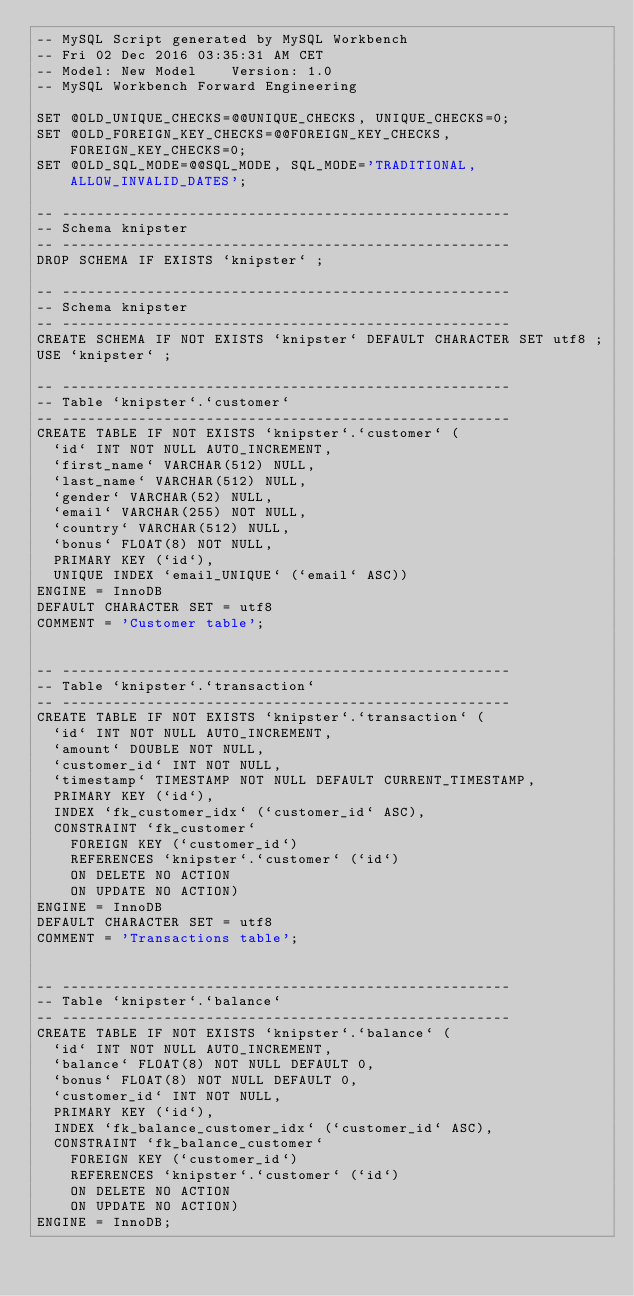<code> <loc_0><loc_0><loc_500><loc_500><_SQL_>-- MySQL Script generated by MySQL Workbench
-- Fri 02 Dec 2016 03:35:31 AM CET
-- Model: New Model    Version: 1.0
-- MySQL Workbench Forward Engineering

SET @OLD_UNIQUE_CHECKS=@@UNIQUE_CHECKS, UNIQUE_CHECKS=0;
SET @OLD_FOREIGN_KEY_CHECKS=@@FOREIGN_KEY_CHECKS, FOREIGN_KEY_CHECKS=0;
SET @OLD_SQL_MODE=@@SQL_MODE, SQL_MODE='TRADITIONAL,ALLOW_INVALID_DATES';

-- -----------------------------------------------------
-- Schema knipster
-- -----------------------------------------------------
DROP SCHEMA IF EXISTS `knipster` ;

-- -----------------------------------------------------
-- Schema knipster
-- -----------------------------------------------------
CREATE SCHEMA IF NOT EXISTS `knipster` DEFAULT CHARACTER SET utf8 ;
USE `knipster` ;

-- -----------------------------------------------------
-- Table `knipster`.`customer`
-- -----------------------------------------------------
CREATE TABLE IF NOT EXISTS `knipster`.`customer` (
  `id` INT NOT NULL AUTO_INCREMENT,
  `first_name` VARCHAR(512) NULL,
  `last_name` VARCHAR(512) NULL,
  `gender` VARCHAR(52) NULL,
  `email` VARCHAR(255) NOT NULL,
  `country` VARCHAR(512) NULL,
  `bonus` FLOAT(8) NOT NULL,
  PRIMARY KEY (`id`),
  UNIQUE INDEX `email_UNIQUE` (`email` ASC))
ENGINE = InnoDB
DEFAULT CHARACTER SET = utf8
COMMENT = 'Customer table';


-- -----------------------------------------------------
-- Table `knipster`.`transaction`
-- -----------------------------------------------------
CREATE TABLE IF NOT EXISTS `knipster`.`transaction` (
  `id` INT NOT NULL AUTO_INCREMENT,
  `amount` DOUBLE NOT NULL,
  `customer_id` INT NOT NULL,
  `timestamp` TIMESTAMP NOT NULL DEFAULT CURRENT_TIMESTAMP,
  PRIMARY KEY (`id`),
  INDEX `fk_customer_idx` (`customer_id` ASC),
  CONSTRAINT `fk_customer`
    FOREIGN KEY (`customer_id`)
    REFERENCES `knipster`.`customer` (`id`)
    ON DELETE NO ACTION
    ON UPDATE NO ACTION)
ENGINE = InnoDB
DEFAULT CHARACTER SET = utf8
COMMENT = 'Transactions table';


-- -----------------------------------------------------
-- Table `knipster`.`balance`
-- -----------------------------------------------------
CREATE TABLE IF NOT EXISTS `knipster`.`balance` (
  `id` INT NOT NULL AUTO_INCREMENT,
  `balance` FLOAT(8) NOT NULL DEFAULT 0,
  `bonus` FLOAT(8) NOT NULL DEFAULT 0,
  `customer_id` INT NOT NULL,
  PRIMARY KEY (`id`),
  INDEX `fk_balance_customer_idx` (`customer_id` ASC),
  CONSTRAINT `fk_balance_customer`
    FOREIGN KEY (`customer_id`)
    REFERENCES `knipster`.`customer` (`id`)
    ON DELETE NO ACTION
    ON UPDATE NO ACTION)
ENGINE = InnoDB;

</code> 